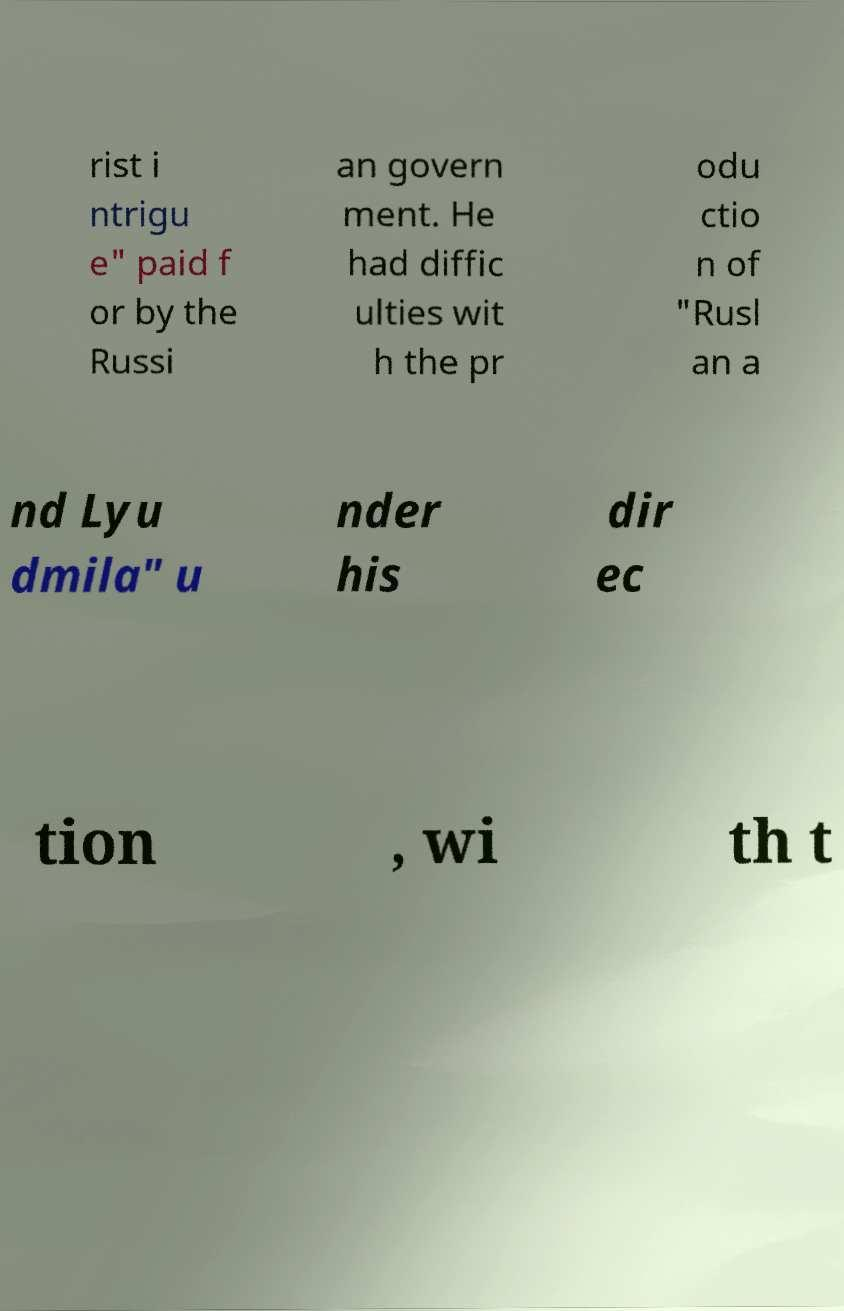Please read and relay the text visible in this image. What does it say? rist i ntrigu e" paid f or by the Russi an govern ment. He had diffic ulties wit h the pr odu ctio n of "Rusl an a nd Lyu dmila" u nder his dir ec tion , wi th t 